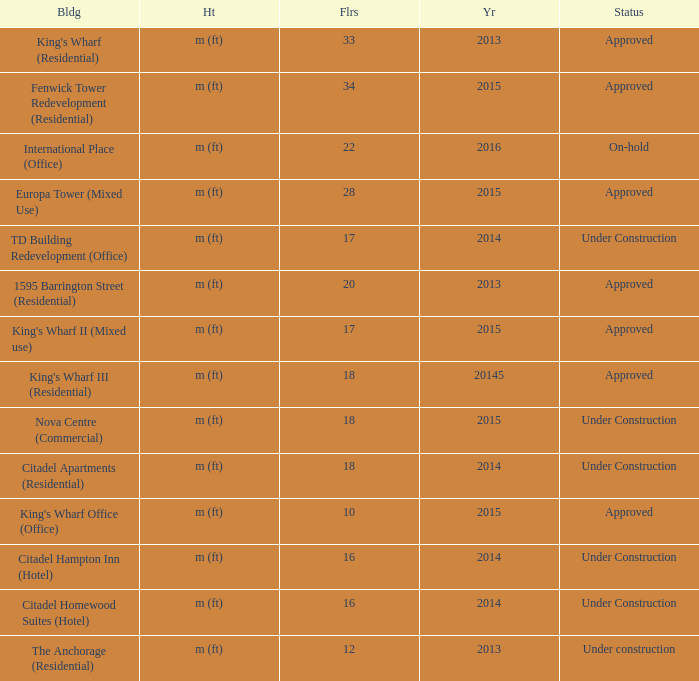What building shows 2013 and has more than 20 floors? King's Wharf (Residential). 